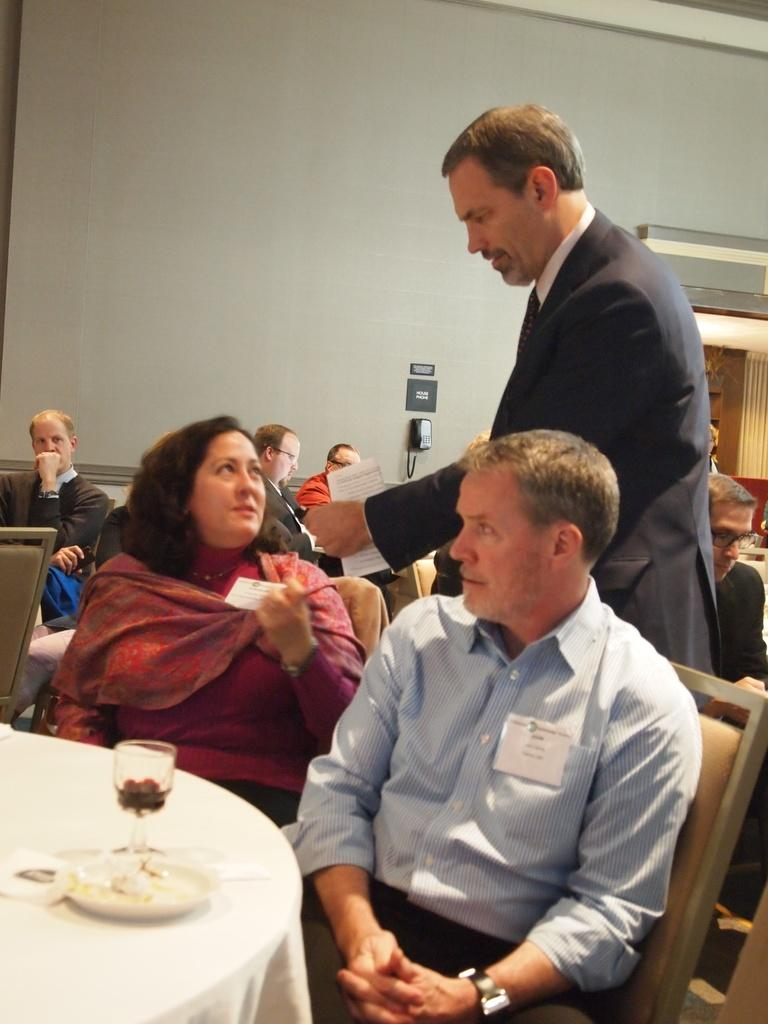What are the two people in the image doing? The man and woman are sitting on chairs in the image. What is located in front of the man and woman? There is a table in front of them. What type of weather can be seen in the image? The image does not provide any information about the weather. Can you tell me how many robins are present in the image? There are no robins present in the image. 